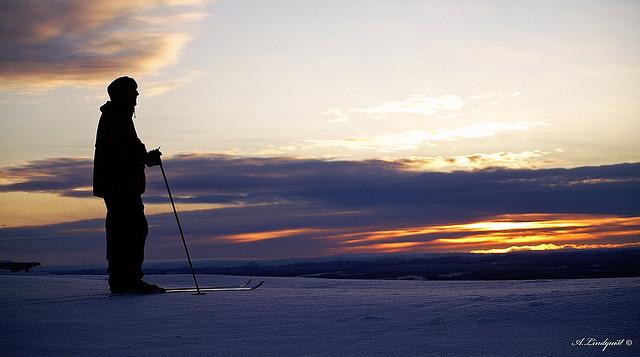What is in the person's hand?
Concise answer only. Ski pole. Are there clouds in the sky?
Quick response, please. Yes. Are the people at the beach?
Give a very brief answer. No. What object can you see between the person's hands?
Keep it brief. Ski pole. What is the weather?
Concise answer only. Cold. What time of day is it in this scene?
Short answer required. Sunset. 